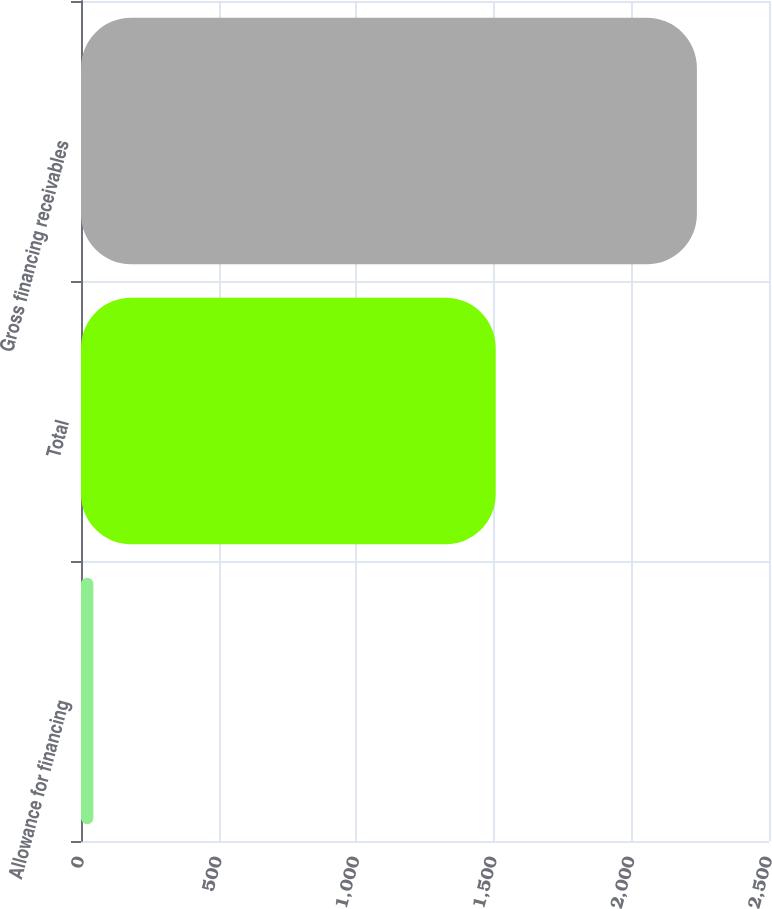Convert chart to OTSL. <chart><loc_0><loc_0><loc_500><loc_500><bar_chart><fcel>Allowance for financing<fcel>Total<fcel>Gross financing receivables<nl><fcel>45<fcel>1507<fcel>2238<nl></chart> 